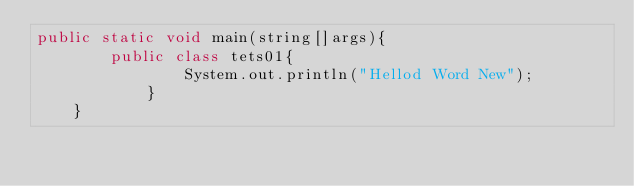Convert code to text. <code><loc_0><loc_0><loc_500><loc_500><_Java_>public static void main(string[]args){
		public class tets01{
				System.out.println("Hellod Word New");
			}
	}</code> 